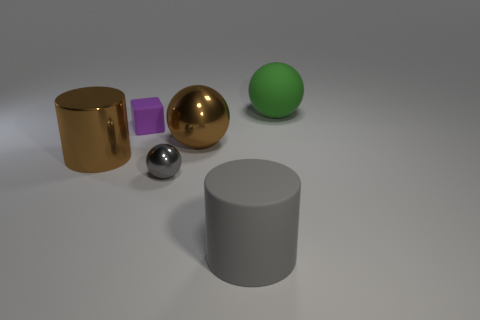There is a brown object that is to the left of the tiny shiny object that is in front of the small purple cube; is there a tiny metallic sphere that is behind it?
Your response must be concise. No. How many large brown shiny cylinders are there?
Give a very brief answer. 1. How many things are either big cylinders left of the gray cylinder or large matte objects that are in front of the green matte thing?
Offer a very short reply. 2. Does the sphere that is behind the rubber cube have the same size as the gray ball?
Offer a very short reply. No. What is the size of the green thing that is the same shape as the tiny gray shiny thing?
Your answer should be compact. Large. There is a gray thing that is the same size as the purple matte block; what is it made of?
Provide a succinct answer. Metal. There is a green thing that is the same shape as the small gray metal object; what is it made of?
Make the answer very short. Rubber. What number of other things are the same size as the block?
Ensure brevity in your answer.  1. There is a cylinder that is the same color as the small metal ball; what is its size?
Provide a short and direct response. Large. How many metallic balls have the same color as the small matte cube?
Ensure brevity in your answer.  0. 